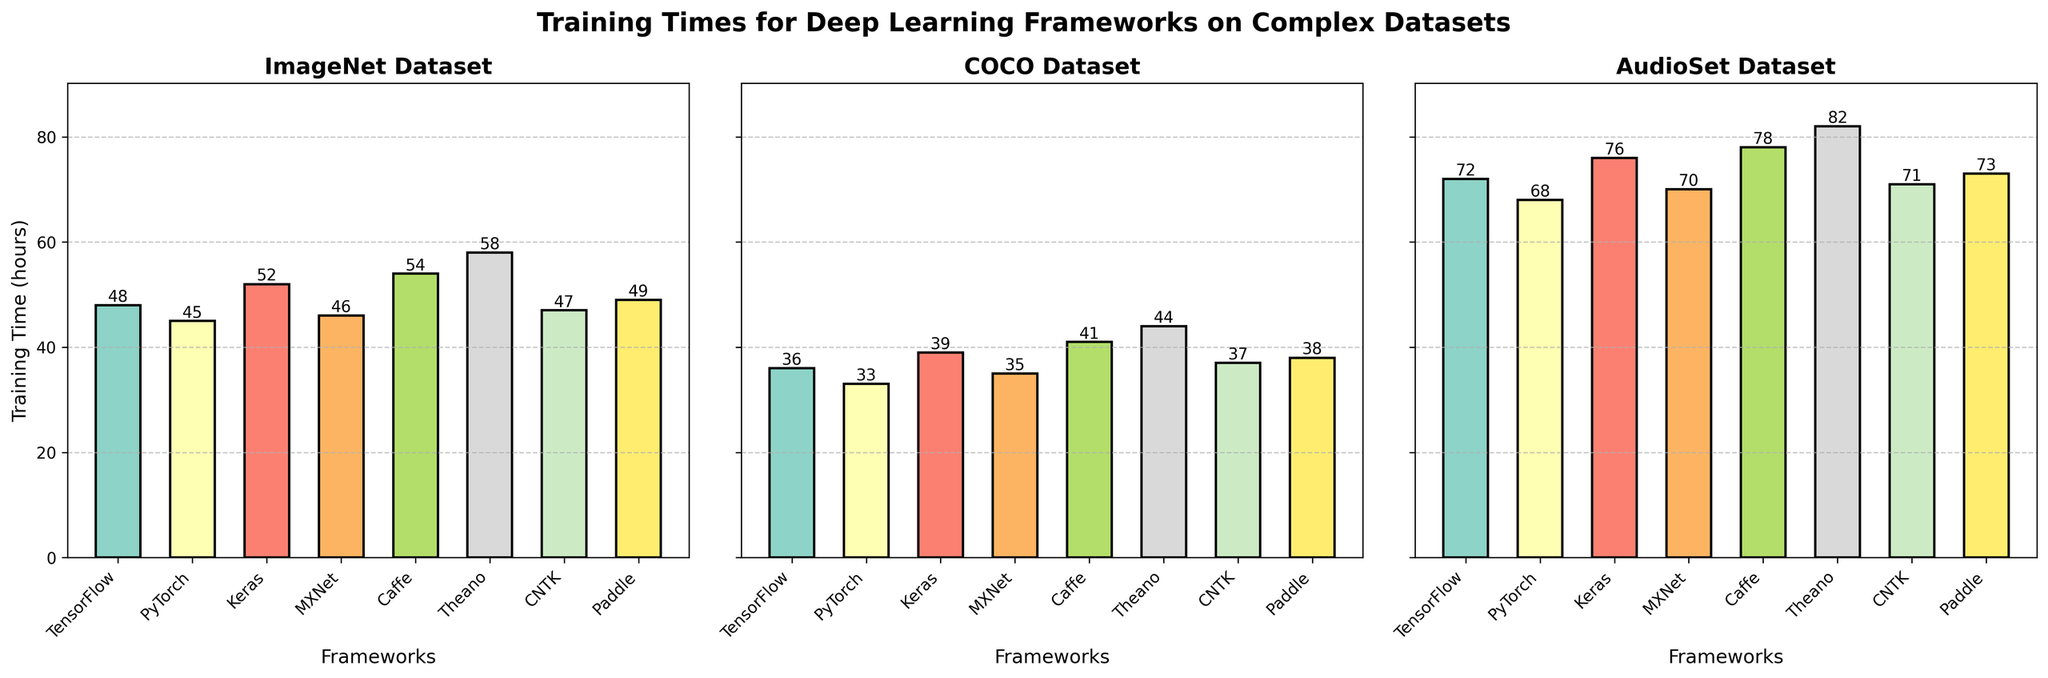Which framework takes the longest time to train on the COCO dataset? The longest training time on the COCO dataset can be identified by looking at the tallest bar in the subplot labeled 'COCO Dataset'. The tallest bar corresponds to the framework labeled 'Theano'.
Answer: Theano Which framework has the shortest training time on the ImageNet dataset? The shortest training time on the ImageNet dataset can be identified by looking at the shortest bar in the subplot labeled 'ImageNet Dataset'. The shortest bar corresponds to the framework labeled 'PyTorch'.
Answer: PyTorch How much longer does it take for Theano to train on the AudioSet dataset compared to PyTorch? Find the training times of Theano and PyTorch for the AudioSet dataset by looking at the heights of the corresponding bars in the AudioSet subplot. Theano takes 82 hours, and PyTorch takes 68 hours. The difference is 82 - 68 = 14 hours.
Answer: 14 hours Which dataset, on average, requires the most training time across all frameworks? Calculate the average training time for each dataset by adding the training times for all frameworks and dividing by the number of frameworks. The averages are as follows:
ImageNet: (48+45+52+46+54+58+47+49)/8,
COCO: (36+33+39+35+41+44+37+38)/8,
AudioSet: (72+68+76+70+78+82+71+73)/8.
Find the dataset with the highest average.
Answer: AudioSet Which framework shows the smallest variation in training times across the datasets? To determine the framework with the smallest variation, calculate the range (difference between maximum and minimum training times) for each framework:
TensorFlow: 72-36,
PyTorch: 68-33,
Keras: 76-39,
MXNet: 70-35,
Caffe: 78-41,
Theano: 82-44,
CNTK: 71-37,
Paddle: 73-38.
The framework with the smallest range has the smallest variation.
Answer: PyTorch Does any framework have the same training time for more than one dataset? Check each framework's training times across the three datasets for any repeated values. None of the frameworks have the same training time across more than one dataset.
Answer: No If you were to prioritize the framework with the least training time for the AudioSet dataset, which would you choose? Identify the shortest bar in the AudioSet subplot. The framework with the shortest bar in the AudioSet dataset is PyTorch.
Answer: PyTorch How does the training time of Caffe on the ImageNet dataset compare to Keras on the same dataset? Look at the heights of the bars for Caffe and Keras in the ImageNet subplot. Caffe takes 54 hours, and Keras takes 52 hours, so Caffe takes 2 hours more than Keras.
Answer: 2 hours more What is the average training time for TensorFlow across all datasets? Sum the training times of TensorFlow for each dataset and divide by the number of datasets. (48 + 36 + 72)/3 = 156/3 = 52 hours
Answer: 52 hours Compare the longest training time of any framework to the shortest training time. How much greater is it? The longest training time is Theano on the AudioSet dataset (82 hours), and the shortest training time is PyTorch on the COCO dataset (33 hours). The difference is 82 - 33 = 49 hours.
Answer: 49 hours 